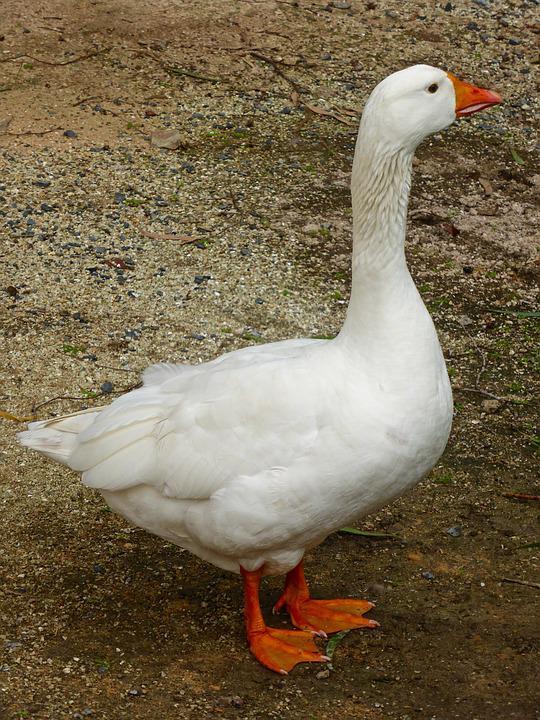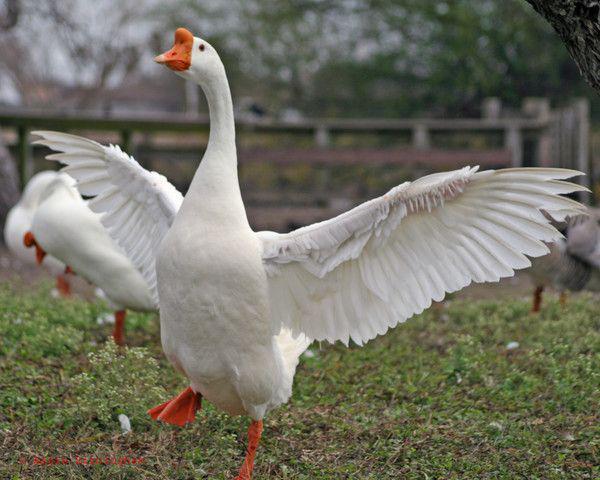The first image is the image on the left, the second image is the image on the right. For the images shown, is this caption "There are at least two animals in every image." true? Answer yes or no. No. 